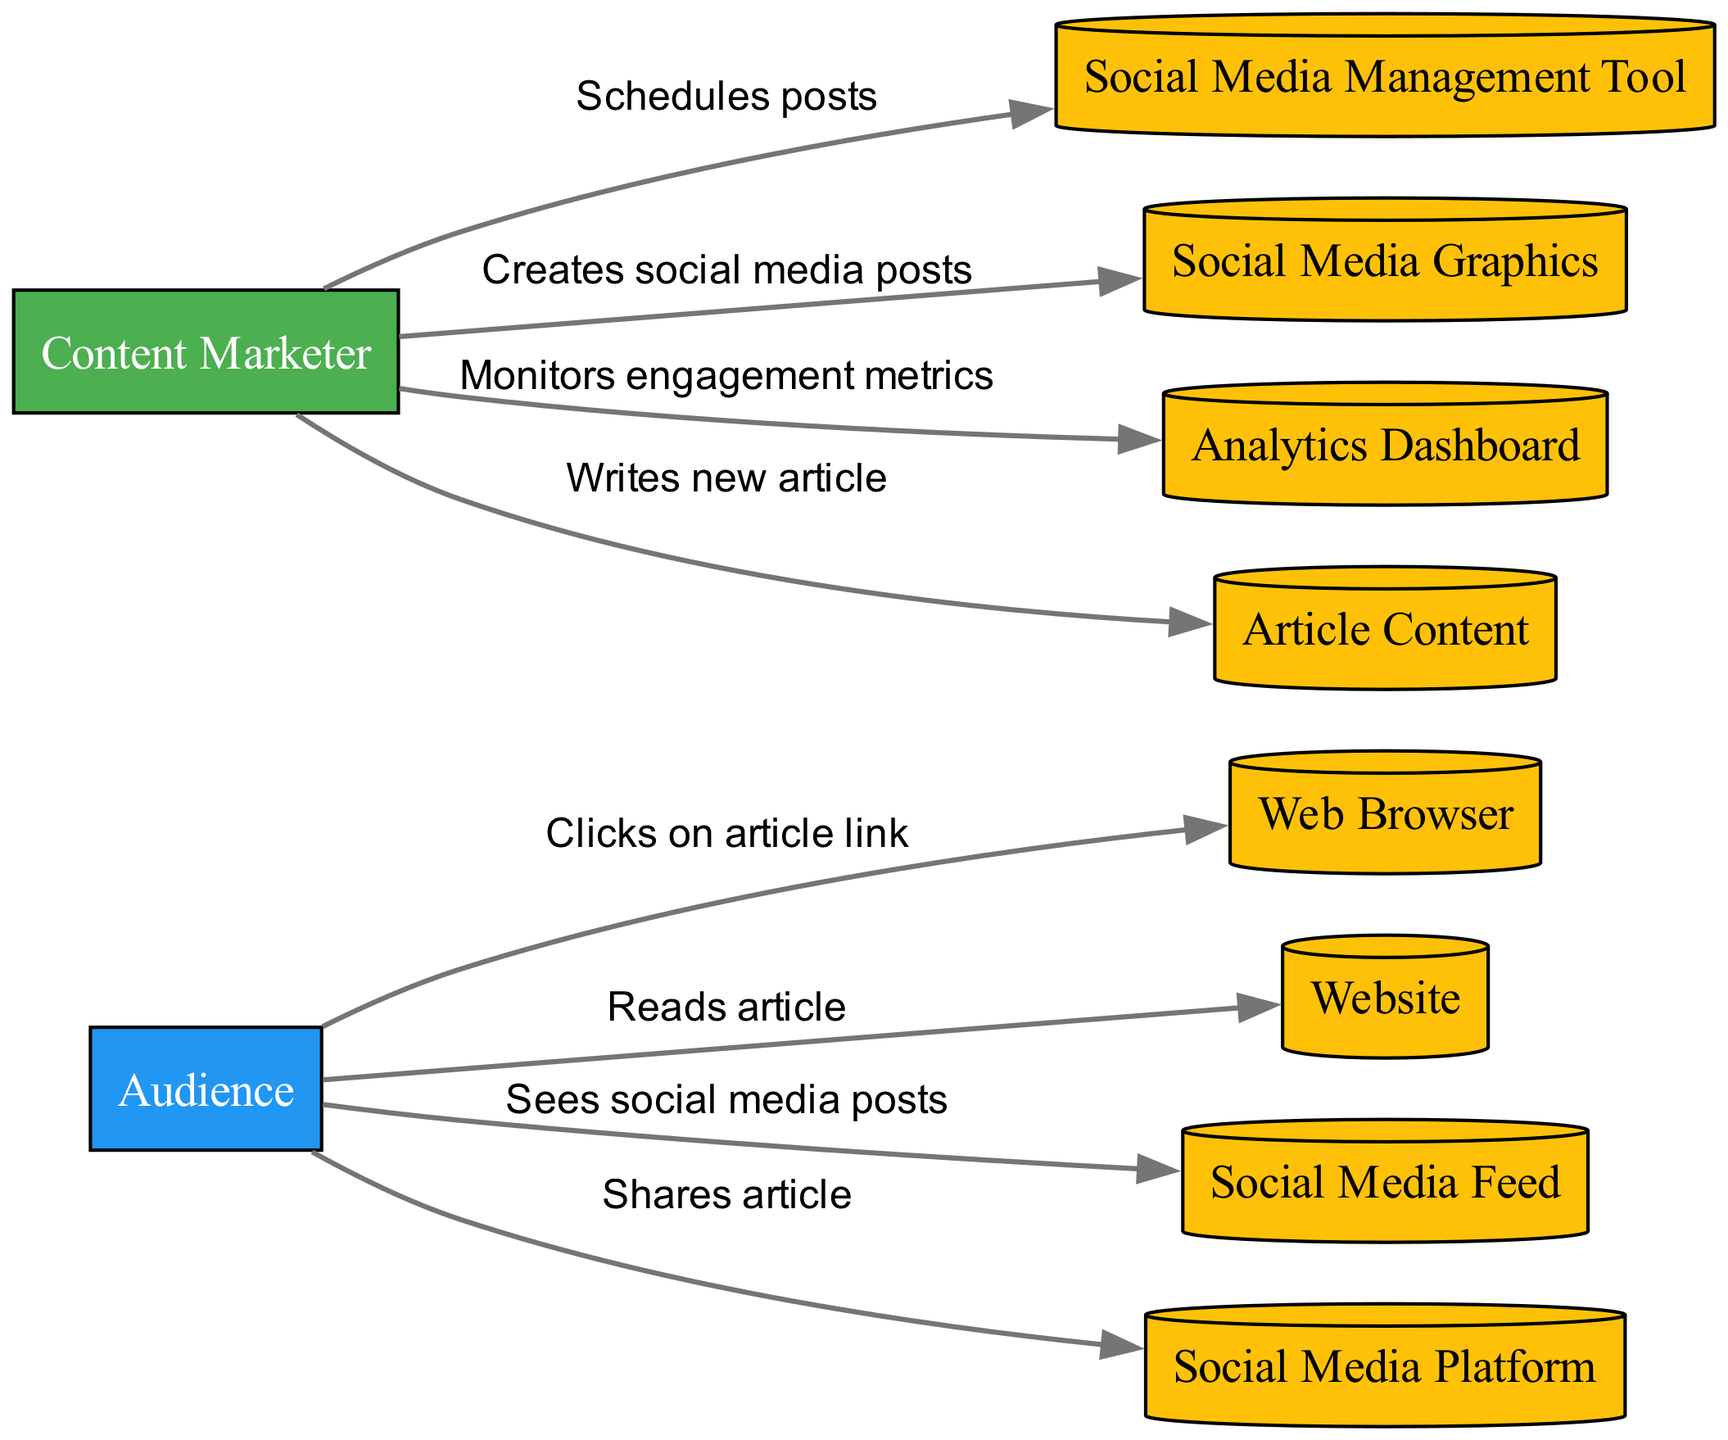What is the first action taken by the Content Marketer? The diagram shows that the first action taken by the Content Marketer is to write the new article, as indicated at the start of the flow.
Answer: Writes new article How many actions are performed by the Audience? By reviewing the diagram, we see that the Audience performs three distinct actions: sees the social media posts, clicks on the article link, and shares the article. Therefore, when counting these actions, we find there are three.
Answer: 3 What resource is utilized for scheduling posts? In the diagram, the Content Marketer's action of scheduling posts is associated with the resource of the Social Media Management Tool. This relationship provides a clear link between the action and the specific resource used.
Answer: Social Media Management Tool Which actor monitors engagement metrics? The diagram indicates that the Content Marketer is responsible for monitoring engagement metrics, as explicitly stated in the last action in the flow of the sequence.
Answer: Content Marketer Which resource does the Audience use to read the article? According to the diagram, the Audience reads the article through the resource identified as the Website, which is connected to the action read article.
Answer: Website How many total interactions are shown between the Content Marketer and the resources? By examining the diagram, we track the number of connections (edges) that involve the Content Marketer interacting with different resources. There are four actions connected to resources: writes new article, creates social media posts, schedules posts, and monitors engagement metrics, leading to a total of four interactions.
Answer: 4 What is the last action in the diagram? The final action shown in the flow of the diagram is the Content Marketer monitoring engagement metrics, which marks the end of the social media sharing process sequence.
Answer: Monitors engagement metrics Which actor initiates interaction with social media posts? According to the diagram, the Audience is depicted as the actor that first interacts with the social media posts, as they see the posts right after the Content Marketer creates them.
Answer: Audience 